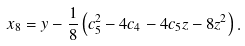Convert formula to latex. <formula><loc_0><loc_0><loc_500><loc_500>x _ { 8 } = y - \frac { 1 } { 8 } \left ( c _ { 5 } ^ { 2 } - 4 c _ { 4 } - 4 c _ { 5 } z - 8 z ^ { 2 } \right ) .</formula> 